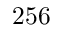Convert formula to latex. <formula><loc_0><loc_0><loc_500><loc_500>2 5 6</formula> 